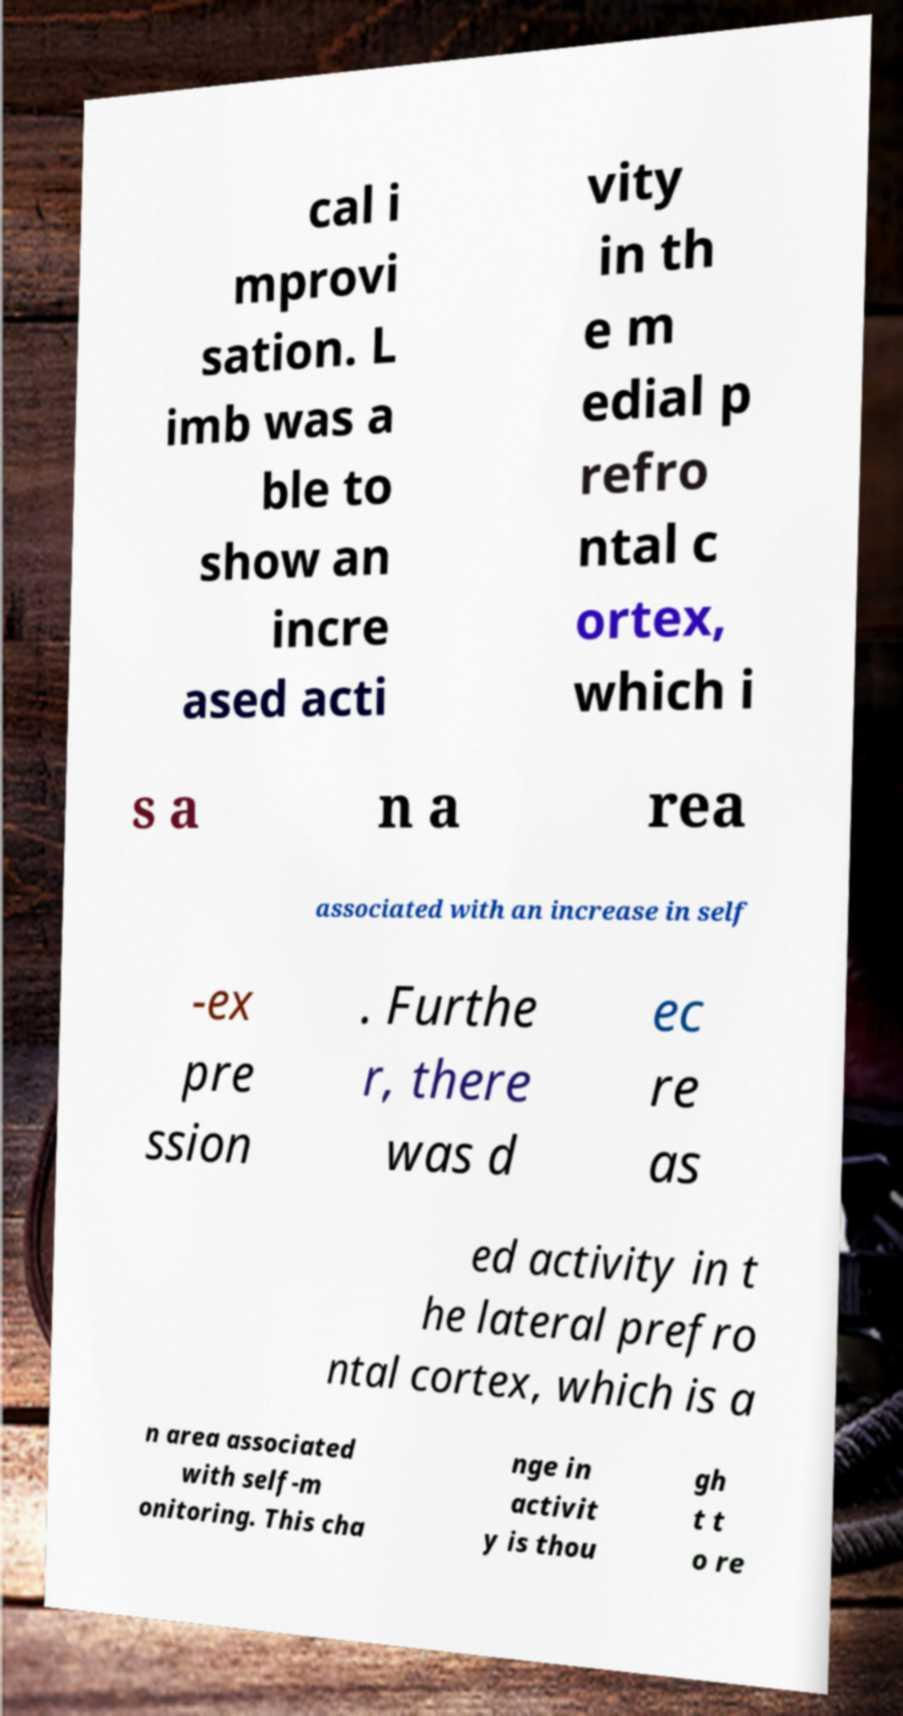There's text embedded in this image that I need extracted. Can you transcribe it verbatim? cal i mprovi sation. L imb was a ble to show an incre ased acti vity in th e m edial p refro ntal c ortex, which i s a n a rea associated with an increase in self -ex pre ssion . Furthe r, there was d ec re as ed activity in t he lateral prefro ntal cortex, which is a n area associated with self-m onitoring. This cha nge in activit y is thou gh t t o re 